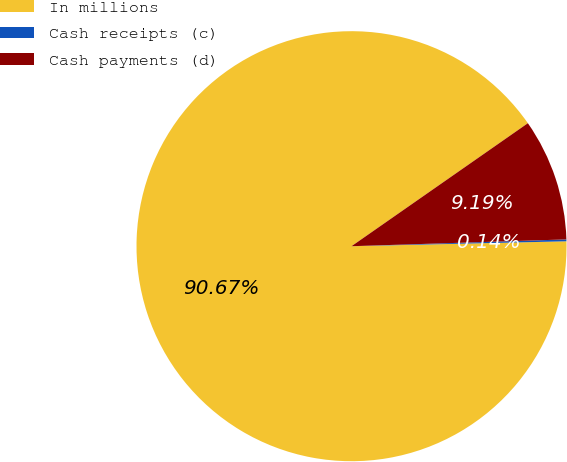Convert chart to OTSL. <chart><loc_0><loc_0><loc_500><loc_500><pie_chart><fcel>In millions<fcel>Cash receipts (c)<fcel>Cash payments (d)<nl><fcel>90.68%<fcel>0.14%<fcel>9.19%<nl></chart> 